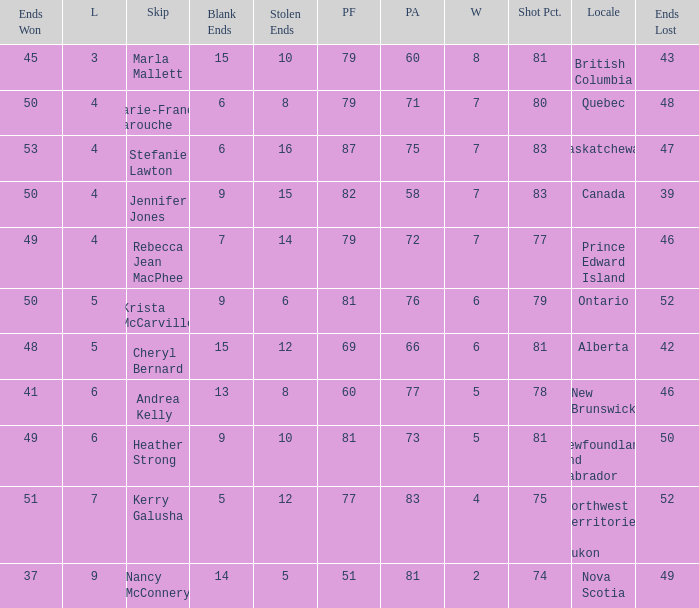What is the pf for Rebecca Jean Macphee? 79.0. 